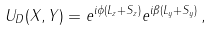<formula> <loc_0><loc_0><loc_500><loc_500>U _ { D } ( X , Y ) = e ^ { i \phi ( L _ { z } + S _ { z } ) } e ^ { i \beta ( L _ { y } + S _ { y } ) } \, ,</formula> 